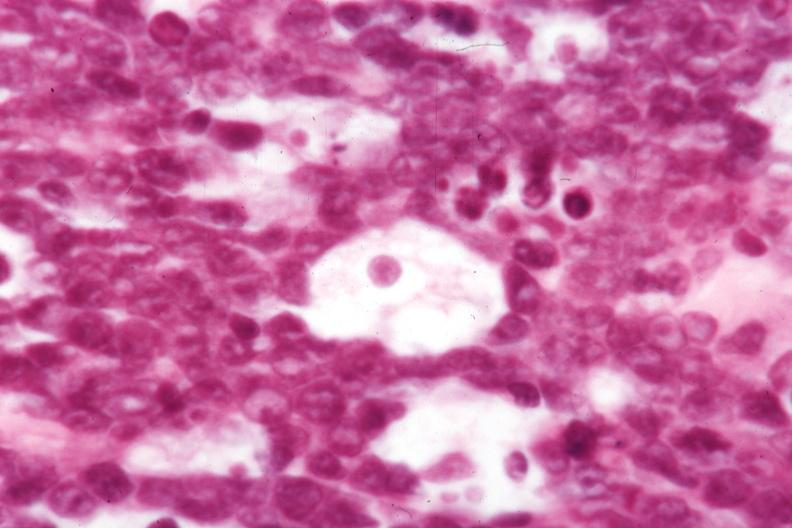does this image show not the best histology?
Answer the question using a single word or phrase. Yes 